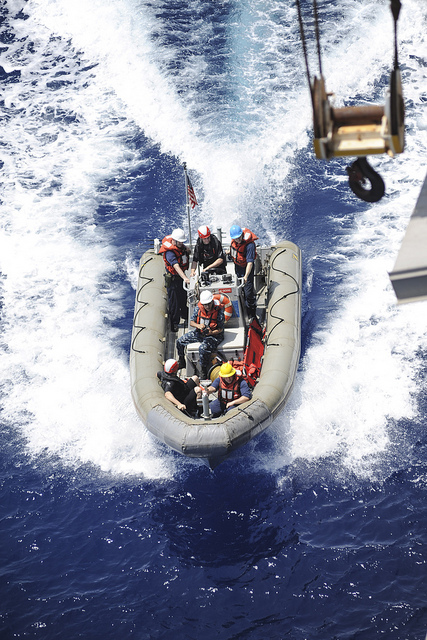<image>What type of boat is shown in the water? I don't know what type of boat is shown in the water. It can be an inflatable, motor boat, raft or speedboat. What type of boat is shown in the water? I am not sure what type of boat is shown in the water. It can be either inflatable, motor, raft, speedboat or motorized raft. 